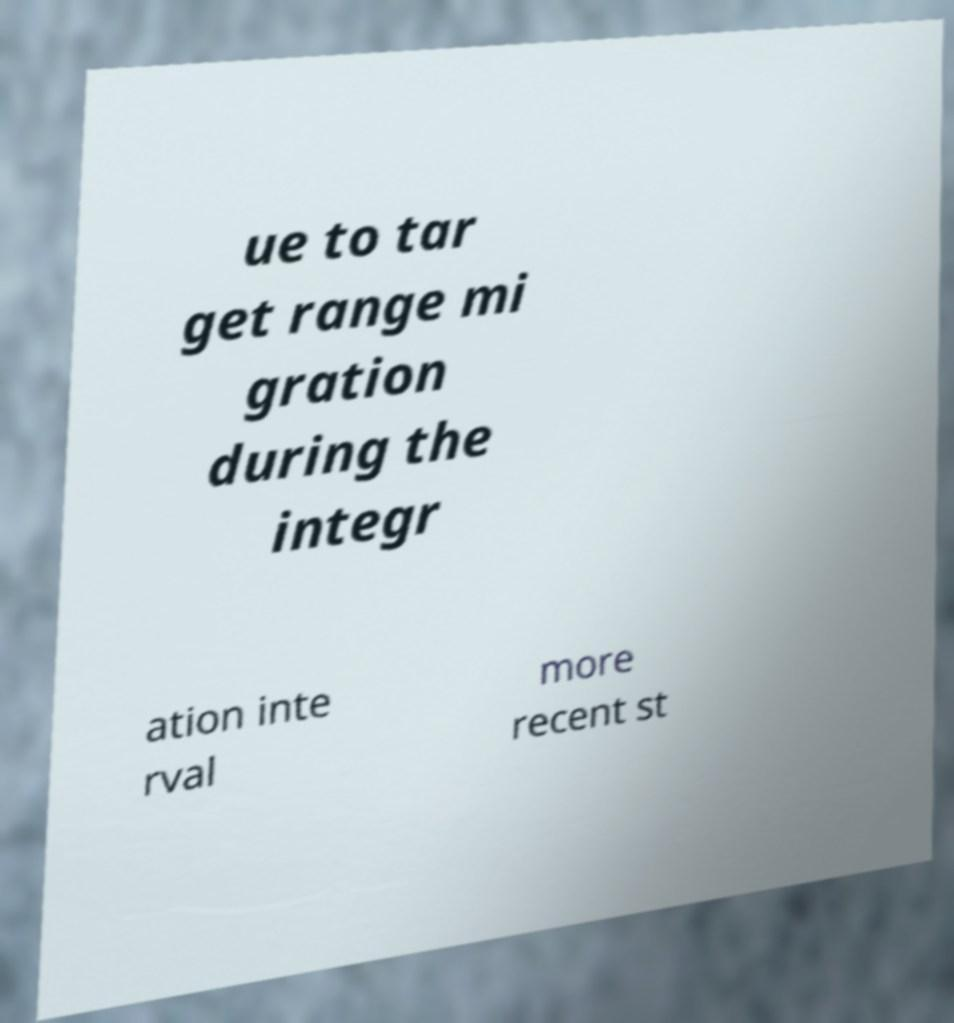Could you extract and type out the text from this image? ue to tar get range mi gration during the integr ation inte rval more recent st 